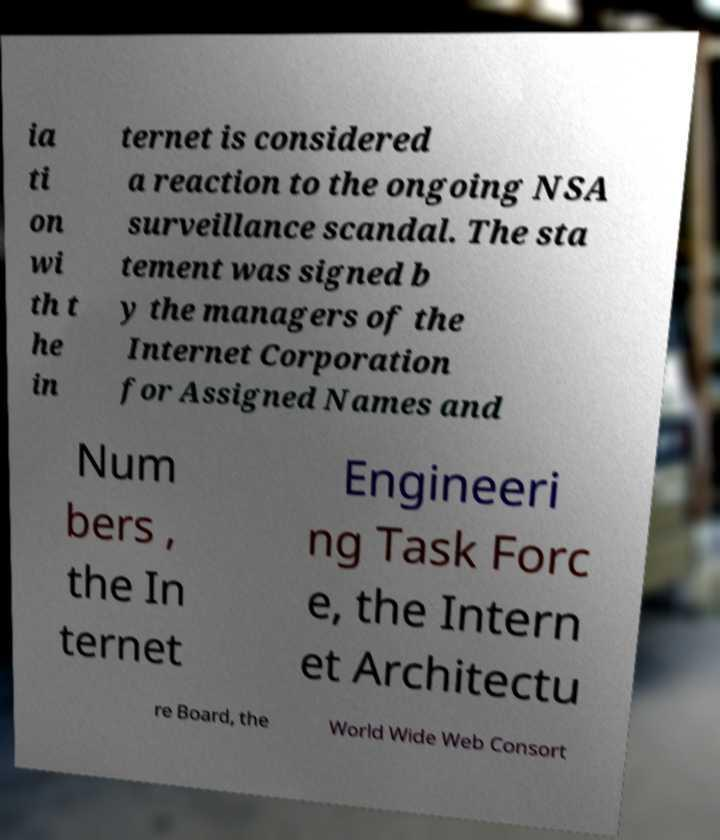Please identify and transcribe the text found in this image. ia ti on wi th t he in ternet is considered a reaction to the ongoing NSA surveillance scandal. The sta tement was signed b y the managers of the Internet Corporation for Assigned Names and Num bers , the In ternet Engineeri ng Task Forc e, the Intern et Architectu re Board, the World Wide Web Consort 